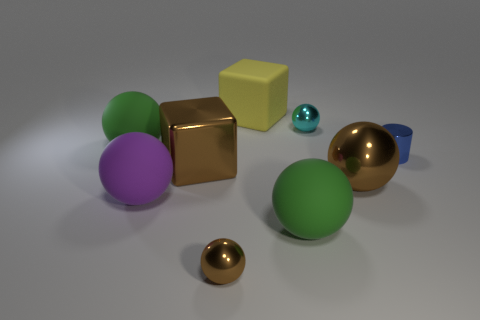Subtract 3 balls. How many balls are left? 3 Subtract all purple balls. How many balls are left? 5 Subtract all small brown balls. How many balls are left? 5 Subtract all gray spheres. Subtract all blue cylinders. How many spheres are left? 6 Subtract all cylinders. How many objects are left? 8 Subtract all tiny metallic spheres. Subtract all matte blocks. How many objects are left? 6 Add 7 green balls. How many green balls are left? 9 Add 5 large brown metal spheres. How many large brown metal spheres exist? 6 Subtract 0 cyan blocks. How many objects are left? 9 